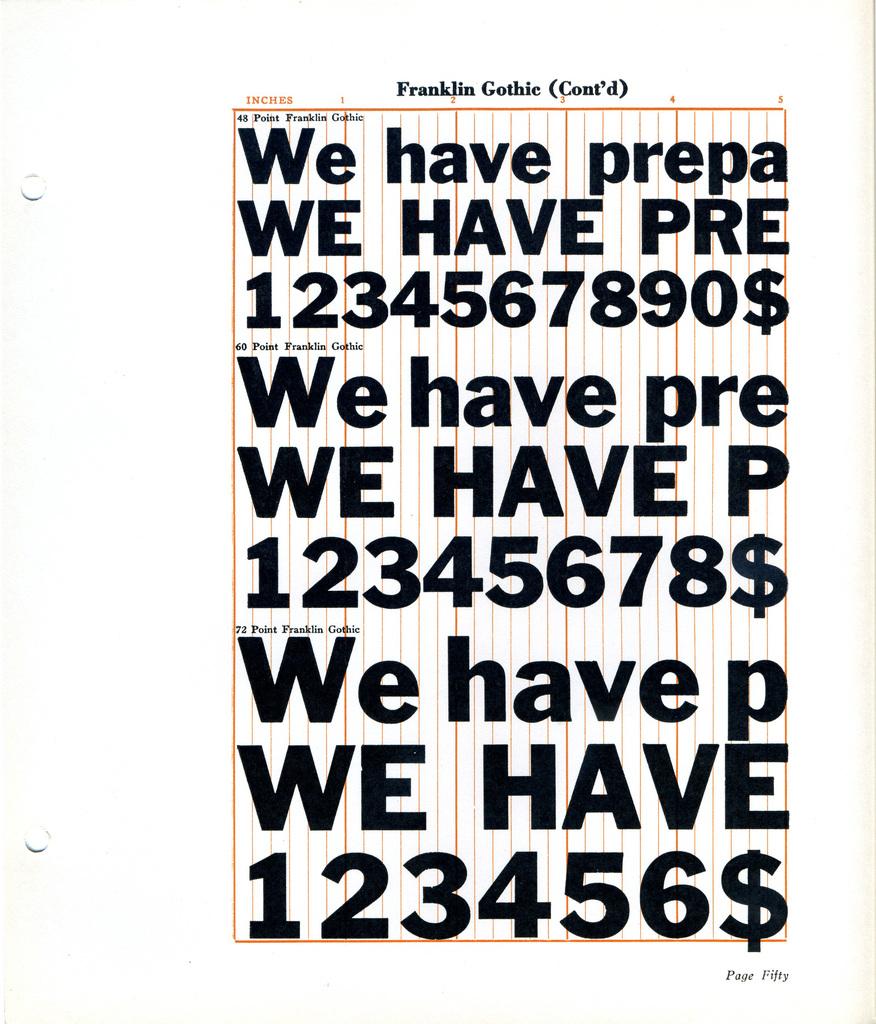What does the first line have written on it?
Provide a succinct answer. We have prepa. 